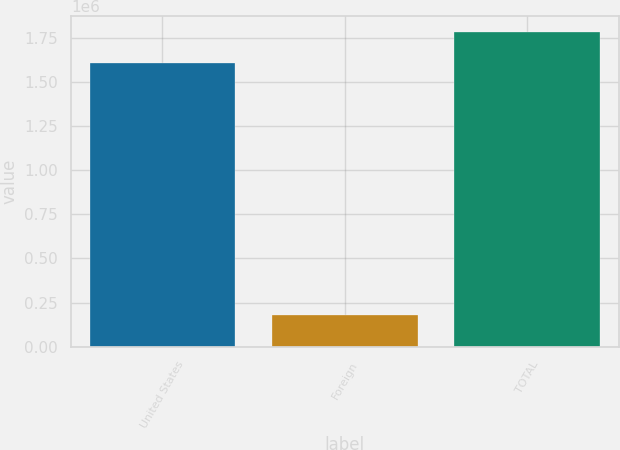Convert chart to OTSL. <chart><loc_0><loc_0><loc_500><loc_500><bar_chart><fcel>United States<fcel>Foreign<fcel>TOTAL<nl><fcel>1.60693e+06<fcel>177074<fcel>1.784e+06<nl></chart> 